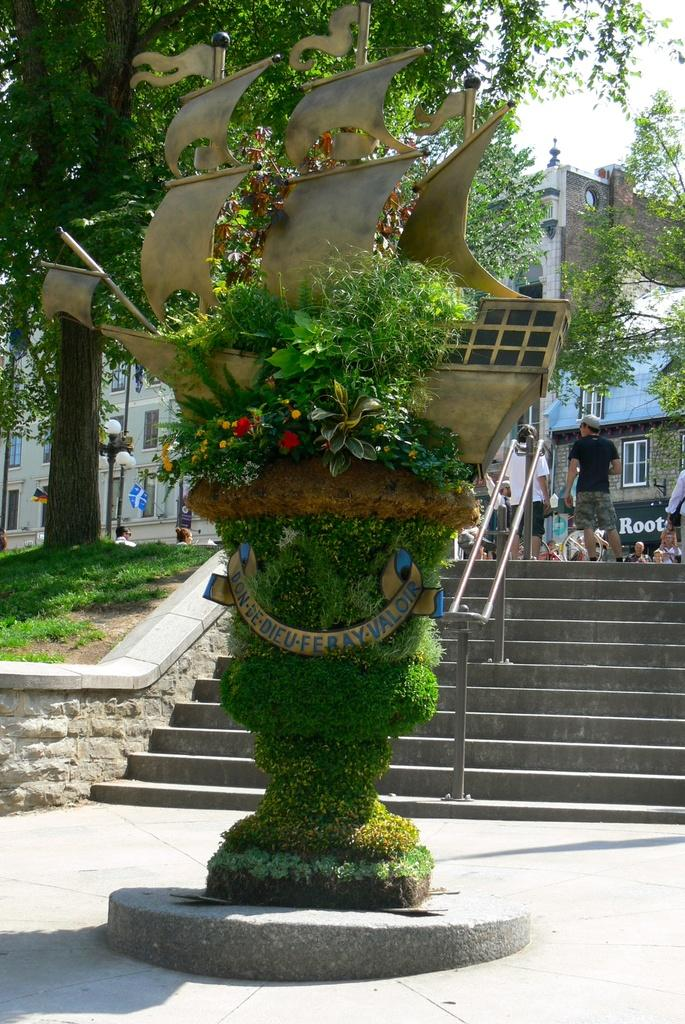How many people can be seen in the image? There are people in the image, but the exact number is not specified. What type of architectural feature is present in the image? There is a staircase in the image. What type of natural elements are present in the image? Trees, flowers, and plants are visible in the image. What type of man-made structure is present in the image? There is a light pole in the image. What type of building is present in the image? Buildings are present in the image. What type of vehicle is present in the image? There is a ship in the image. What part of the natural environment is visible in the image? The sky is visible in the image. What type of button is being used to control the invention in the image? There is no button or invention present in the image. What type of roof is visible on the buildings in the image? The image does not show the roofs of the buildings, so it cannot be determined from the image. 